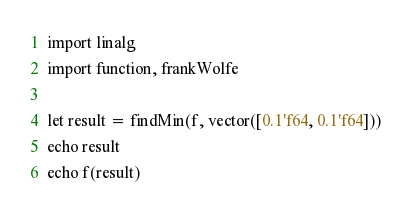<code> <loc_0><loc_0><loc_500><loc_500><_Nim_>import linalg
import function, frankWolfe

let result = findMin(f, vector([0.1'f64, 0.1'f64]))
echo result
echo f(result)

</code> 